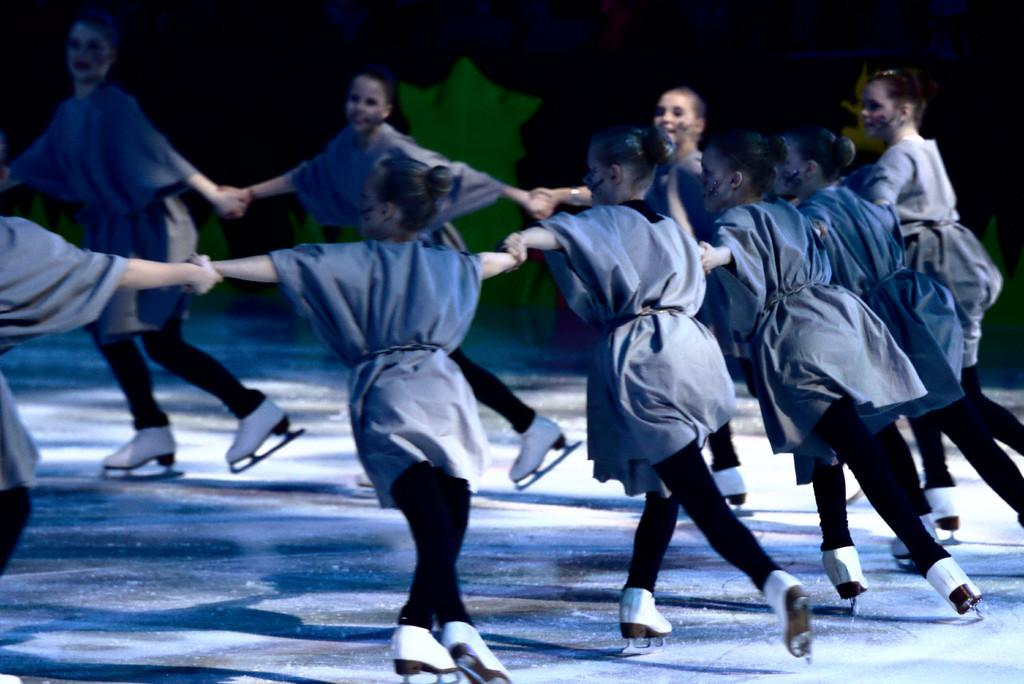How many people are in the image? There are people in the image, but the exact number is not specified. What are the people doing in the image? The people are holding hands, skating, and dancing in the image. What can be seen in the background of the image? The background of the image is dark, and there are objects visible in the background. What type of tin is being twisted by the people in the image? There is no tin or twisting action present in the image; the people are holding hands, skating, and dancing. 